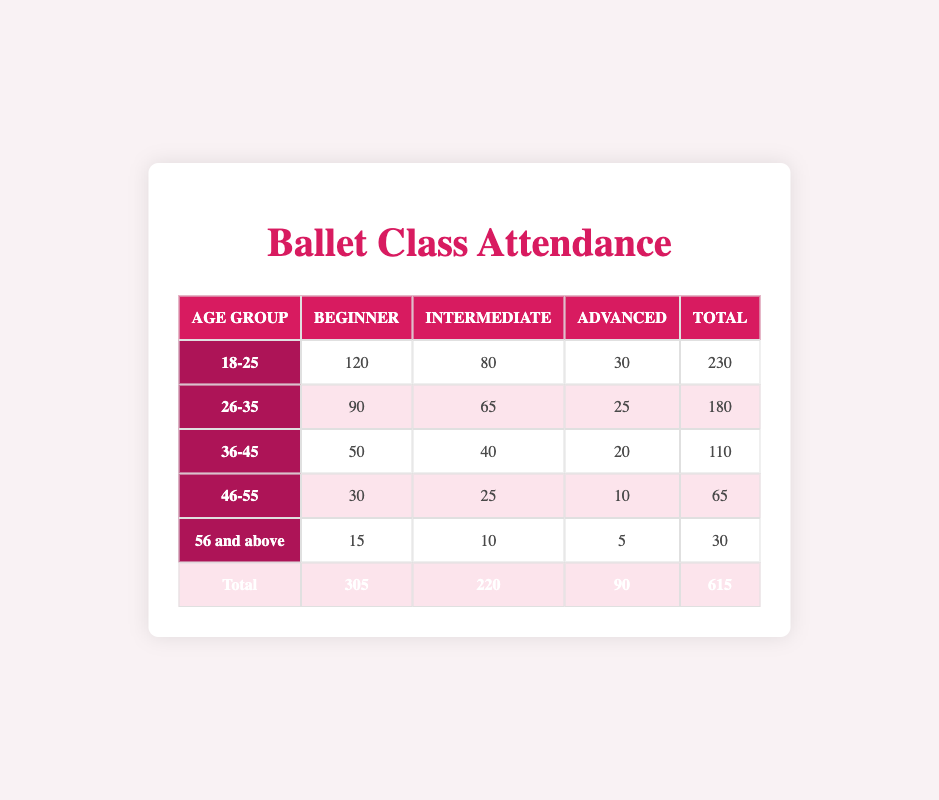What is the total attendance for the age group 18-25? The total attendance for the age group 18-25 is found in the last column of the corresponding row. It shows 230.
Answer: 230 How many Beginner attendees are there in the age group 36-45? From the table, the attendance count for the Beginner level in the 36-45 age group is given directly in that row as 50.
Answer: 50 Is there a higher attendance in the Intermediate level or Advanced level for the age group 26-35? In the 26-35 age group, the Intermediate attendance is 65 and Advanced attendance is 25. Since 65 is greater than 25, the answer is yes.
Answer: Yes What is the combined attendance of the Beginner level across all age groups? Adding up the attendance of Beginner level from all age groups: 120 (18-25) + 90 (26-35) + 50 (36-45) + 30 (46-55) + 15 (56 and above) = 305.
Answer: 305 Which age group has the least number of attendees at the Advanced level? Looking at the Advanced level attendance, the counts are 30 (18-25), 25 (26-35), 20 (36-45), 10 (46-55), and 5 (56 and above). The least is 5 in the 56 and above age group.
Answer: 56 and above What percentage of attendees in the age group 46-55 are Beginner level? The attendance for Beginners in the 46-55 age group is 30, with a total of 65 attendees. The percentage is calculated as (30/65) * 100, which equals approximately 46.15%.
Answer: 46.15% Is the total attendance for age groups 18-25 and 26-35 greater than that of age groups 46-55 and 56 and above combined? The total for 18-25 and 26-35 is 230 + 180 = 410, while for 46-55 and 56 and above it's 65 + 30 = 95. Since 410 is greater than 95, the answer is yes.
Answer: Yes How many more Intermediate attendees are there in the age group 18-25 compared to the age group 36-45? The Intermediate attendance in age group 18-25 is 80, and in 36-45 it is 40. Calculating the difference gives us 80 - 40 = 40.
Answer: 40 What is the total attendance across all age groups and skill levels? The total is found in the last row of the table, which sums all attendees: 305 (Beginner) + 220 (Intermediate) + 90 (Advanced) = 615.
Answer: 615 